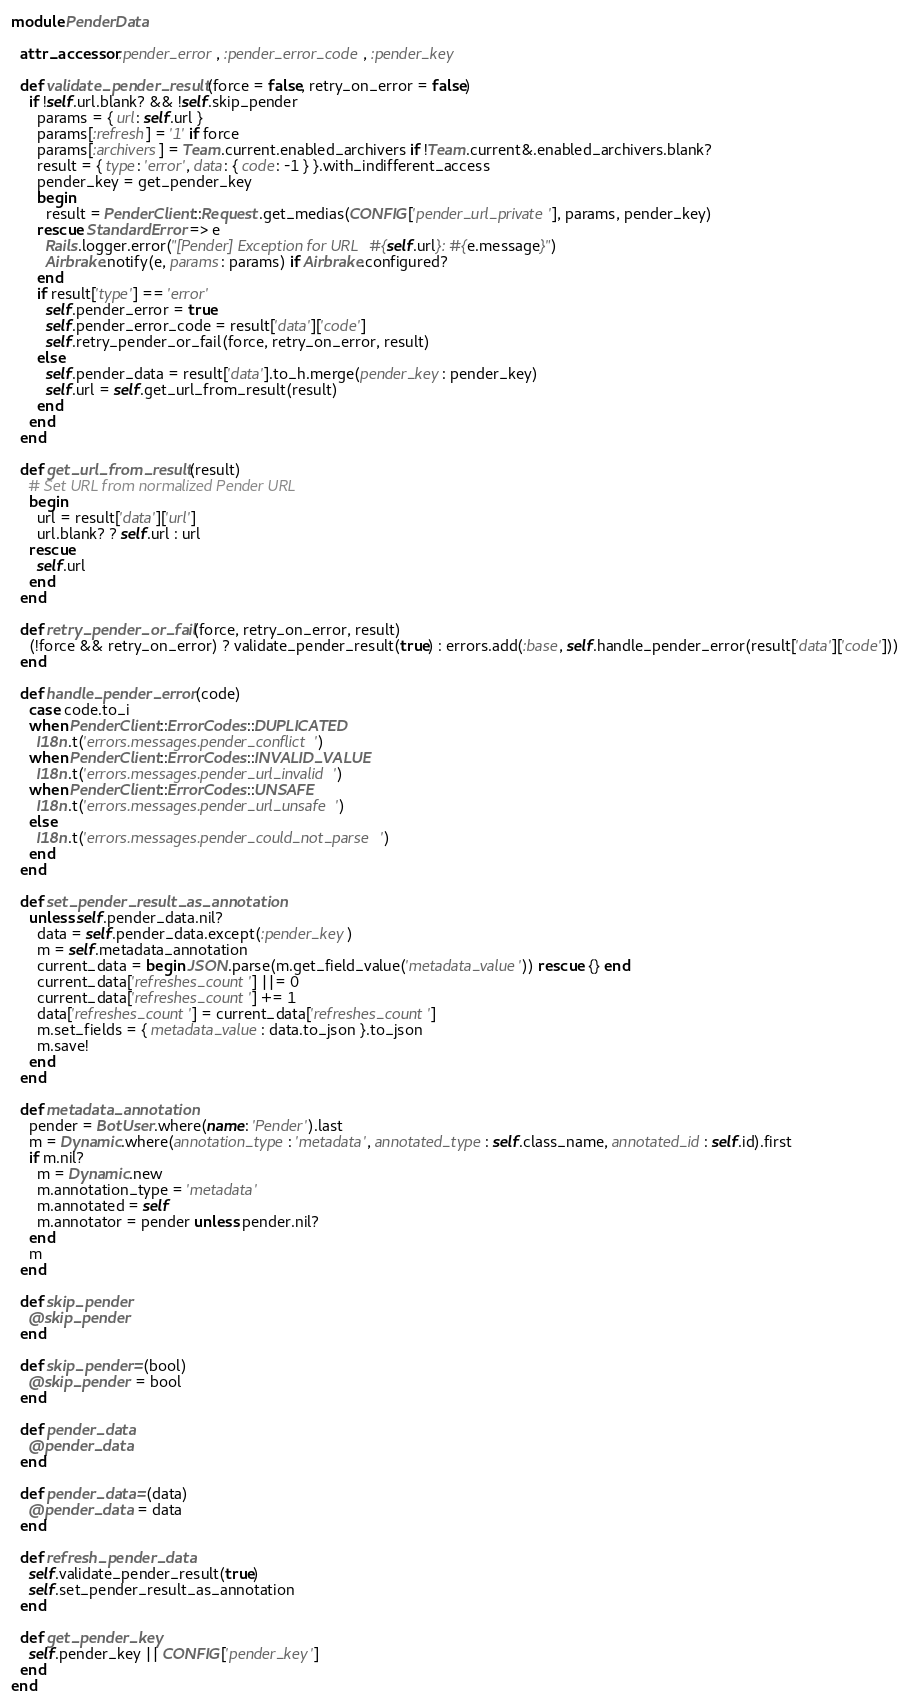<code> <loc_0><loc_0><loc_500><loc_500><_Ruby_>module PenderData

  attr_accessor :pender_error, :pender_error_code, :pender_key

  def validate_pender_result(force = false, retry_on_error = false)
    if !self.url.blank? && !self.skip_pender
      params = { url: self.url }
      params[:refresh] = '1' if force
      params[:archivers] = Team.current.enabled_archivers if !Team.current&.enabled_archivers.blank?
      result = { type: 'error', data: { code: -1 } }.with_indifferent_access
      pender_key = get_pender_key
      begin
        result = PenderClient::Request.get_medias(CONFIG['pender_url_private'], params, pender_key)
      rescue StandardError => e
        Rails.logger.error("[Pender] Exception for URL #{self.url}: #{e.message}")
        Airbrake.notify(e, params: params) if Airbrake.configured?
      end
      if result['type'] == 'error'
        self.pender_error = true
        self.pender_error_code = result['data']['code']
        self.retry_pender_or_fail(force, retry_on_error, result)
      else
        self.pender_data = result['data'].to_h.merge(pender_key: pender_key)
        self.url = self.get_url_from_result(result)
      end
    end
  end

  def get_url_from_result(result)
    # Set URL from normalized Pender URL
    begin
      url = result['data']['url']
      url.blank? ? self.url : url
    rescue
      self.url
    end
  end

  def retry_pender_or_fail(force, retry_on_error, result)
    (!force && retry_on_error) ? validate_pender_result(true) : errors.add(:base, self.handle_pender_error(result['data']['code']))
  end

  def handle_pender_error(code)
    case code.to_i
    when PenderClient::ErrorCodes::DUPLICATED
      I18n.t('errors.messages.pender_conflict')
    when PenderClient::ErrorCodes::INVALID_VALUE
      I18n.t('errors.messages.pender_url_invalid')
    when PenderClient::ErrorCodes::UNSAFE
      I18n.t('errors.messages.pender_url_unsafe')
    else
      I18n.t('errors.messages.pender_could_not_parse')
    end
  end

  def set_pender_result_as_annotation
    unless self.pender_data.nil?
      data = self.pender_data.except(:pender_key)
      m = self.metadata_annotation
      current_data = begin JSON.parse(m.get_field_value('metadata_value')) rescue {} end
      current_data['refreshes_count'] ||= 0
      current_data['refreshes_count'] += 1
      data['refreshes_count'] = current_data['refreshes_count']
      m.set_fields = { metadata_value: data.to_json }.to_json
      m.save!
    end
  end

  def metadata_annotation
    pender = BotUser.where(name: 'Pender').last
    m = Dynamic.where(annotation_type: 'metadata', annotated_type: self.class_name, annotated_id: self.id).first
    if m.nil?
      m = Dynamic.new
      m.annotation_type = 'metadata'
      m.annotated = self
      m.annotator = pender unless pender.nil?
    end
    m
  end

  def skip_pender
    @skip_pender
  end

  def skip_pender=(bool)
    @skip_pender = bool
  end

  def pender_data
    @pender_data
  end

  def pender_data=(data)
    @pender_data = data
  end

  def refresh_pender_data
    self.validate_pender_result(true)
    self.set_pender_result_as_annotation
  end

  def get_pender_key
    self.pender_key || CONFIG['pender_key']
  end
end
</code> 